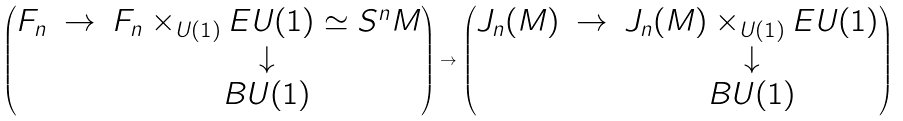<formula> <loc_0><loc_0><loc_500><loc_500>\left ( \begin{matrix} F _ { n } & \rightarrow & F _ { n } \times _ { U ( 1 ) } E U ( 1 ) \simeq S ^ { n } M \\ & & \downarrow \\ & & B U ( 1 ) \end{matrix} \right ) \rightarrow \left ( \begin{matrix} J _ { n } ( M ) & \rightarrow & J _ { n } ( M ) \times _ { U ( 1 ) } E U ( 1 ) \\ & & \downarrow \\ & & B U ( 1 ) \end{matrix} \right )</formula> 